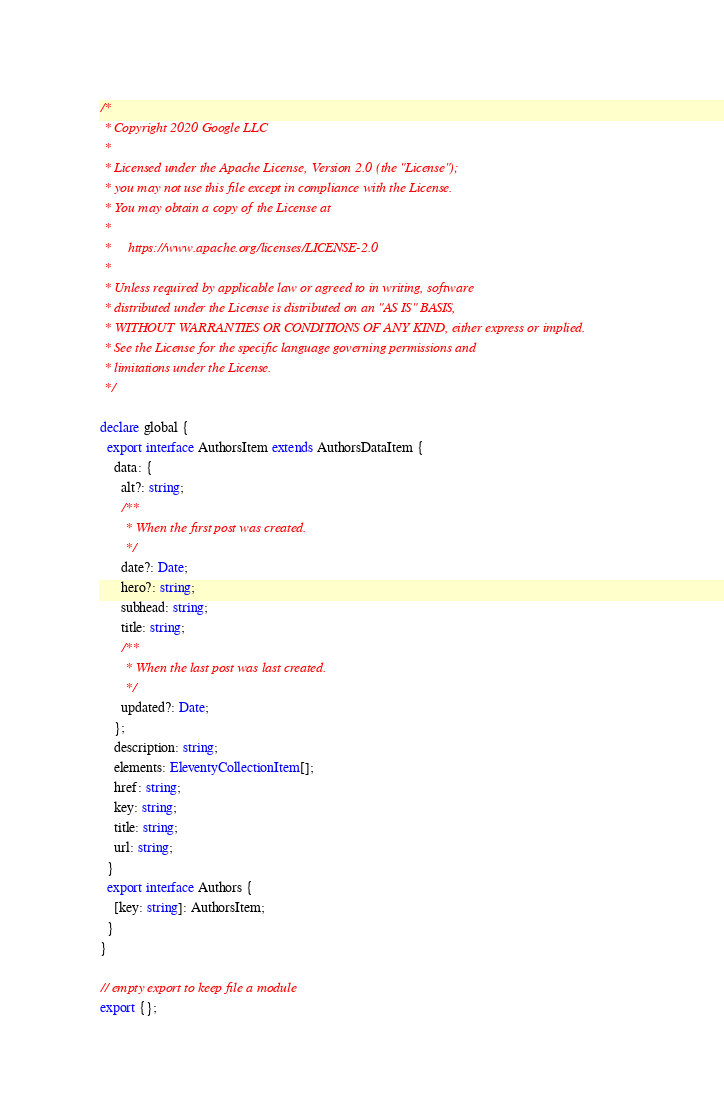Convert code to text. <code><loc_0><loc_0><loc_500><loc_500><_TypeScript_>/*
 * Copyright 2020 Google LLC
 *
 * Licensed under the Apache License, Version 2.0 (the "License");
 * you may not use this file except in compliance with the License.
 * You may obtain a copy of the License at
 *
 *     https://www.apache.org/licenses/LICENSE-2.0
 *
 * Unless required by applicable law or agreed to in writing, software
 * distributed under the License is distributed on an "AS IS" BASIS,
 * WITHOUT WARRANTIES OR CONDITIONS OF ANY KIND, either express or implied.
 * See the License for the specific language governing permissions and
 * limitations under the License.
 */

declare global {
  export interface AuthorsItem extends AuthorsDataItem {
    data: {
      alt?: string;
      /**
       * When the first post was created.
       */
      date?: Date;
      hero?: string;
      subhead: string;
      title: string;
      /**
       * When the last post was last created.
       */
      updated?: Date;
    };
    description: string;
    elements: EleventyCollectionItem[];
    href: string;
    key: string;
    title: string;
    url: string;
  }
  export interface Authors {
    [key: string]: AuthorsItem;
  }
}

// empty export to keep file a module
export {};
</code> 